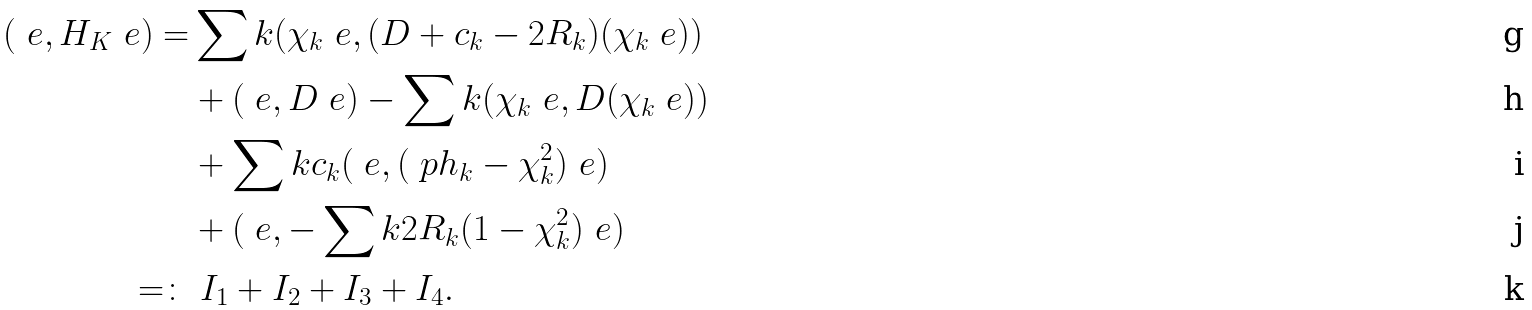<formula> <loc_0><loc_0><loc_500><loc_500>( \ e , H _ { K } \ e ) = & \sum k ( \chi _ { k } \ e , ( D + c _ { k } - 2 R _ { k } ) ( \chi _ { k } \ e ) ) \\ & + ( \ e , D \ e ) - \sum k ( \chi _ { k } \ e , D ( \chi _ { k } \ e ) ) \\ & + \sum k c _ { k } ( \ e , ( \ p h _ { k } - \chi _ { k } ^ { 2 } ) \ e ) \\ & + ( \ e , - \sum k 2 R _ { k } ( 1 - \chi _ { k } ^ { 2 } ) \ e ) \\ = \colon & \ I _ { 1 } + I _ { 2 } + I _ { 3 } + I _ { 4 } .</formula> 